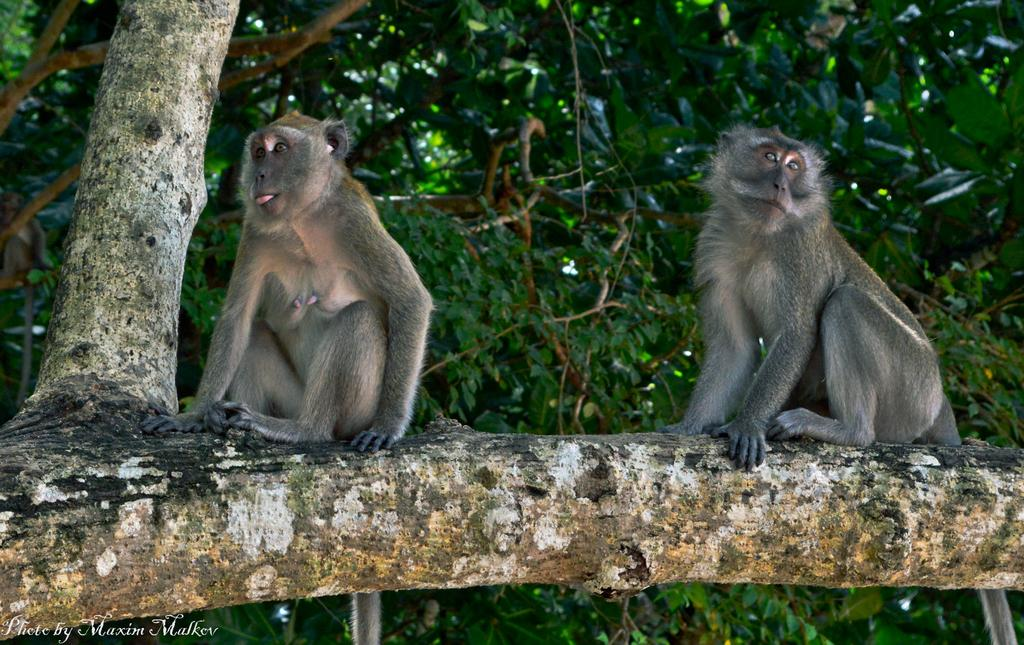How many monkeys are in the image? There are two monkeys in the image. Where are the monkeys located in the image? The monkeys are sitting on a branch of a tree. What can be seen in the background of the image? There are trees in the background of the image. What type of shoes are the monkeys wearing in the image? There are no shoes present in the image, as monkeys do not typically wear shoes. 